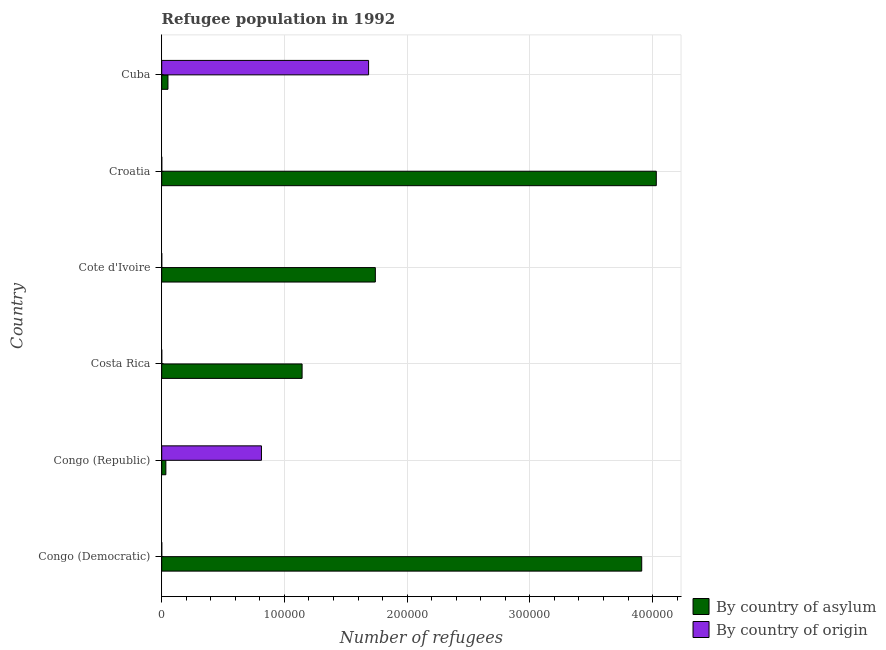How many different coloured bars are there?
Your answer should be compact. 2. How many groups of bars are there?
Provide a succinct answer. 6. Are the number of bars per tick equal to the number of legend labels?
Ensure brevity in your answer.  Yes. What is the label of the 1st group of bars from the top?
Your response must be concise. Cuba. What is the number of refugees by country of asylum in Croatia?
Provide a succinct answer. 4.03e+05. Across all countries, what is the maximum number of refugees by country of asylum?
Keep it short and to the point. 4.03e+05. Across all countries, what is the minimum number of refugees by country of origin?
Your answer should be compact. 2. In which country was the number of refugees by country of asylum maximum?
Your answer should be compact. Croatia. In which country was the number of refugees by country of asylum minimum?
Keep it short and to the point. Congo (Republic). What is the total number of refugees by country of asylum in the graph?
Make the answer very short. 1.09e+06. What is the difference between the number of refugees by country of origin in Congo (Republic) and that in Cuba?
Keep it short and to the point. -8.73e+04. What is the difference between the number of refugees by country of origin in Costa Rica and the number of refugees by country of asylum in Cote d'Ivoire?
Offer a very short reply. -1.74e+05. What is the average number of refugees by country of origin per country?
Provide a succinct answer. 4.16e+04. What is the difference between the number of refugees by country of origin and number of refugees by country of asylum in Congo (Republic)?
Offer a terse response. 7.79e+04. What is the ratio of the number of refugees by country of origin in Cote d'Ivoire to that in Cuba?
Your response must be concise. 0. Is the number of refugees by country of asylum in Congo (Democratic) less than that in Cote d'Ivoire?
Provide a short and direct response. No. Is the difference between the number of refugees by country of asylum in Costa Rica and Croatia greater than the difference between the number of refugees by country of origin in Costa Rica and Croatia?
Your answer should be compact. No. What is the difference between the highest and the second highest number of refugees by country of origin?
Provide a succinct answer. 8.73e+04. What is the difference between the highest and the lowest number of refugees by country of asylum?
Give a very brief answer. 4.00e+05. In how many countries, is the number of refugees by country of asylum greater than the average number of refugees by country of asylum taken over all countries?
Your answer should be very brief. 2. Is the sum of the number of refugees by country of asylum in Congo (Democratic) and Cuba greater than the maximum number of refugees by country of origin across all countries?
Your answer should be compact. Yes. What does the 2nd bar from the top in Congo (Democratic) represents?
Your answer should be very brief. By country of asylum. What does the 1st bar from the bottom in Cuba represents?
Give a very brief answer. By country of asylum. How many bars are there?
Keep it short and to the point. 12. Does the graph contain any zero values?
Ensure brevity in your answer.  No. Does the graph contain grids?
Give a very brief answer. Yes. Where does the legend appear in the graph?
Provide a short and direct response. Bottom right. How many legend labels are there?
Offer a terse response. 2. How are the legend labels stacked?
Your answer should be very brief. Vertical. What is the title of the graph?
Provide a succinct answer. Refugee population in 1992. Does "Non-residents" appear as one of the legend labels in the graph?
Your answer should be compact. No. What is the label or title of the X-axis?
Provide a succinct answer. Number of refugees. What is the label or title of the Y-axis?
Your response must be concise. Country. What is the Number of refugees in By country of asylum in Congo (Democratic)?
Your answer should be very brief. 3.91e+05. What is the Number of refugees of By country of origin in Congo (Democratic)?
Keep it short and to the point. 2. What is the Number of refugees in By country of asylum in Congo (Republic)?
Give a very brief answer. 3385. What is the Number of refugees in By country of origin in Congo (Republic)?
Provide a succinct answer. 8.13e+04. What is the Number of refugees of By country of asylum in Costa Rica?
Offer a terse response. 1.14e+05. What is the Number of refugees of By country of asylum in Cote d'Ivoire?
Make the answer very short. 1.74e+05. What is the Number of refugees in By country of asylum in Croatia?
Make the answer very short. 4.03e+05. What is the Number of refugees in By country of origin in Croatia?
Your response must be concise. 34. What is the Number of refugees in By country of asylum in Cuba?
Provide a short and direct response. 5092. What is the Number of refugees in By country of origin in Cuba?
Offer a very short reply. 1.69e+05. Across all countries, what is the maximum Number of refugees in By country of asylum?
Keep it short and to the point. 4.03e+05. Across all countries, what is the maximum Number of refugees in By country of origin?
Provide a short and direct response. 1.69e+05. Across all countries, what is the minimum Number of refugees of By country of asylum?
Ensure brevity in your answer.  3385. Across all countries, what is the minimum Number of refugees in By country of origin?
Provide a succinct answer. 2. What is the total Number of refugees in By country of asylum in the graph?
Your answer should be compact. 1.09e+06. What is the total Number of refugees of By country of origin in the graph?
Your response must be concise. 2.50e+05. What is the difference between the Number of refugees of By country of asylum in Congo (Democratic) and that in Congo (Republic)?
Your response must be concise. 3.88e+05. What is the difference between the Number of refugees of By country of origin in Congo (Democratic) and that in Congo (Republic)?
Provide a succinct answer. -8.13e+04. What is the difference between the Number of refugees of By country of asylum in Congo (Democratic) and that in Costa Rica?
Your answer should be compact. 2.77e+05. What is the difference between the Number of refugees in By country of origin in Congo (Democratic) and that in Costa Rica?
Provide a succinct answer. -5. What is the difference between the Number of refugees of By country of asylum in Congo (Democratic) and that in Cote d'Ivoire?
Give a very brief answer. 2.17e+05. What is the difference between the Number of refugees in By country of origin in Congo (Democratic) and that in Cote d'Ivoire?
Offer a very short reply. -3. What is the difference between the Number of refugees in By country of asylum in Congo (Democratic) and that in Croatia?
Ensure brevity in your answer.  -1.19e+04. What is the difference between the Number of refugees of By country of origin in Congo (Democratic) and that in Croatia?
Ensure brevity in your answer.  -32. What is the difference between the Number of refugees in By country of asylum in Congo (Democratic) and that in Cuba?
Your answer should be compact. 3.86e+05. What is the difference between the Number of refugees of By country of origin in Congo (Democratic) and that in Cuba?
Provide a succinct answer. -1.69e+05. What is the difference between the Number of refugees in By country of asylum in Congo (Republic) and that in Costa Rica?
Your answer should be compact. -1.11e+05. What is the difference between the Number of refugees in By country of origin in Congo (Republic) and that in Costa Rica?
Your response must be concise. 8.13e+04. What is the difference between the Number of refugees of By country of asylum in Congo (Republic) and that in Cote d'Ivoire?
Keep it short and to the point. -1.71e+05. What is the difference between the Number of refugees of By country of origin in Congo (Republic) and that in Cote d'Ivoire?
Your response must be concise. 8.13e+04. What is the difference between the Number of refugees in By country of asylum in Congo (Republic) and that in Croatia?
Ensure brevity in your answer.  -4.00e+05. What is the difference between the Number of refugees of By country of origin in Congo (Republic) and that in Croatia?
Your answer should be very brief. 8.12e+04. What is the difference between the Number of refugees of By country of asylum in Congo (Republic) and that in Cuba?
Give a very brief answer. -1707. What is the difference between the Number of refugees of By country of origin in Congo (Republic) and that in Cuba?
Ensure brevity in your answer.  -8.73e+04. What is the difference between the Number of refugees of By country of asylum in Costa Rica and that in Cote d'Ivoire?
Ensure brevity in your answer.  -5.97e+04. What is the difference between the Number of refugees in By country of origin in Costa Rica and that in Cote d'Ivoire?
Give a very brief answer. 2. What is the difference between the Number of refugees of By country of asylum in Costa Rica and that in Croatia?
Provide a short and direct response. -2.89e+05. What is the difference between the Number of refugees of By country of asylum in Costa Rica and that in Cuba?
Offer a terse response. 1.09e+05. What is the difference between the Number of refugees of By country of origin in Costa Rica and that in Cuba?
Give a very brief answer. -1.69e+05. What is the difference between the Number of refugees in By country of asylum in Cote d'Ivoire and that in Croatia?
Your answer should be very brief. -2.29e+05. What is the difference between the Number of refugees in By country of asylum in Cote d'Ivoire and that in Cuba?
Your answer should be very brief. 1.69e+05. What is the difference between the Number of refugees of By country of origin in Cote d'Ivoire and that in Cuba?
Ensure brevity in your answer.  -1.69e+05. What is the difference between the Number of refugees of By country of asylum in Croatia and that in Cuba?
Offer a terse response. 3.98e+05. What is the difference between the Number of refugees in By country of origin in Croatia and that in Cuba?
Make the answer very short. -1.69e+05. What is the difference between the Number of refugees of By country of asylum in Congo (Democratic) and the Number of refugees of By country of origin in Congo (Republic)?
Your answer should be very brief. 3.10e+05. What is the difference between the Number of refugees in By country of asylum in Congo (Democratic) and the Number of refugees in By country of origin in Costa Rica?
Your response must be concise. 3.91e+05. What is the difference between the Number of refugees in By country of asylum in Congo (Democratic) and the Number of refugees in By country of origin in Cote d'Ivoire?
Provide a succinct answer. 3.91e+05. What is the difference between the Number of refugees of By country of asylum in Congo (Democratic) and the Number of refugees of By country of origin in Croatia?
Give a very brief answer. 3.91e+05. What is the difference between the Number of refugees in By country of asylum in Congo (Democratic) and the Number of refugees in By country of origin in Cuba?
Offer a very short reply. 2.23e+05. What is the difference between the Number of refugees of By country of asylum in Congo (Republic) and the Number of refugees of By country of origin in Costa Rica?
Your answer should be compact. 3378. What is the difference between the Number of refugees of By country of asylum in Congo (Republic) and the Number of refugees of By country of origin in Cote d'Ivoire?
Your answer should be very brief. 3380. What is the difference between the Number of refugees in By country of asylum in Congo (Republic) and the Number of refugees in By country of origin in Croatia?
Your response must be concise. 3351. What is the difference between the Number of refugees in By country of asylum in Congo (Republic) and the Number of refugees in By country of origin in Cuba?
Offer a terse response. -1.65e+05. What is the difference between the Number of refugees in By country of asylum in Costa Rica and the Number of refugees in By country of origin in Cote d'Ivoire?
Your answer should be very brief. 1.14e+05. What is the difference between the Number of refugees in By country of asylum in Costa Rica and the Number of refugees in By country of origin in Croatia?
Offer a terse response. 1.14e+05. What is the difference between the Number of refugees in By country of asylum in Costa Rica and the Number of refugees in By country of origin in Cuba?
Your answer should be very brief. -5.42e+04. What is the difference between the Number of refugees in By country of asylum in Cote d'Ivoire and the Number of refugees in By country of origin in Croatia?
Ensure brevity in your answer.  1.74e+05. What is the difference between the Number of refugees in By country of asylum in Cote d'Ivoire and the Number of refugees in By country of origin in Cuba?
Offer a very short reply. 5505. What is the difference between the Number of refugees of By country of asylum in Croatia and the Number of refugees of By country of origin in Cuba?
Your answer should be compact. 2.34e+05. What is the average Number of refugees of By country of asylum per country?
Your answer should be very brief. 1.82e+05. What is the average Number of refugees in By country of origin per country?
Provide a succinct answer. 4.16e+04. What is the difference between the Number of refugees of By country of asylum and Number of refugees of By country of origin in Congo (Democratic)?
Keep it short and to the point. 3.91e+05. What is the difference between the Number of refugees in By country of asylum and Number of refugees in By country of origin in Congo (Republic)?
Offer a terse response. -7.79e+04. What is the difference between the Number of refugees of By country of asylum and Number of refugees of By country of origin in Costa Rica?
Your answer should be very brief. 1.14e+05. What is the difference between the Number of refugees in By country of asylum and Number of refugees in By country of origin in Cote d'Ivoire?
Provide a succinct answer. 1.74e+05. What is the difference between the Number of refugees in By country of asylum and Number of refugees in By country of origin in Croatia?
Ensure brevity in your answer.  4.03e+05. What is the difference between the Number of refugees of By country of asylum and Number of refugees of By country of origin in Cuba?
Give a very brief answer. -1.63e+05. What is the ratio of the Number of refugees of By country of asylum in Congo (Democratic) to that in Congo (Republic)?
Offer a very short reply. 115.55. What is the ratio of the Number of refugees in By country of origin in Congo (Democratic) to that in Congo (Republic)?
Offer a terse response. 0. What is the ratio of the Number of refugees of By country of asylum in Congo (Democratic) to that in Costa Rica?
Keep it short and to the point. 3.42. What is the ratio of the Number of refugees in By country of origin in Congo (Democratic) to that in Costa Rica?
Your response must be concise. 0.29. What is the ratio of the Number of refugees in By country of asylum in Congo (Democratic) to that in Cote d'Ivoire?
Ensure brevity in your answer.  2.25. What is the ratio of the Number of refugees of By country of origin in Congo (Democratic) to that in Cote d'Ivoire?
Keep it short and to the point. 0.4. What is the ratio of the Number of refugees of By country of asylum in Congo (Democratic) to that in Croatia?
Your response must be concise. 0.97. What is the ratio of the Number of refugees in By country of origin in Congo (Democratic) to that in Croatia?
Give a very brief answer. 0.06. What is the ratio of the Number of refugees in By country of asylum in Congo (Democratic) to that in Cuba?
Your answer should be very brief. 76.81. What is the ratio of the Number of refugees in By country of origin in Congo (Democratic) to that in Cuba?
Offer a very short reply. 0. What is the ratio of the Number of refugees in By country of asylum in Congo (Republic) to that in Costa Rica?
Provide a succinct answer. 0.03. What is the ratio of the Number of refugees in By country of origin in Congo (Republic) to that in Costa Rica?
Provide a short and direct response. 1.16e+04. What is the ratio of the Number of refugees in By country of asylum in Congo (Republic) to that in Cote d'Ivoire?
Ensure brevity in your answer.  0.02. What is the ratio of the Number of refugees of By country of origin in Congo (Republic) to that in Cote d'Ivoire?
Keep it short and to the point. 1.63e+04. What is the ratio of the Number of refugees in By country of asylum in Congo (Republic) to that in Croatia?
Offer a very short reply. 0.01. What is the ratio of the Number of refugees of By country of origin in Congo (Republic) to that in Croatia?
Your response must be concise. 2390.26. What is the ratio of the Number of refugees in By country of asylum in Congo (Republic) to that in Cuba?
Your answer should be compact. 0.66. What is the ratio of the Number of refugees in By country of origin in Congo (Republic) to that in Cuba?
Your answer should be very brief. 0.48. What is the ratio of the Number of refugees in By country of asylum in Costa Rica to that in Cote d'Ivoire?
Offer a very short reply. 0.66. What is the ratio of the Number of refugees in By country of origin in Costa Rica to that in Cote d'Ivoire?
Ensure brevity in your answer.  1.4. What is the ratio of the Number of refugees of By country of asylum in Costa Rica to that in Croatia?
Your response must be concise. 0.28. What is the ratio of the Number of refugees in By country of origin in Costa Rica to that in Croatia?
Make the answer very short. 0.21. What is the ratio of the Number of refugees in By country of asylum in Costa Rica to that in Cuba?
Provide a succinct answer. 22.46. What is the ratio of the Number of refugees of By country of origin in Costa Rica to that in Cuba?
Keep it short and to the point. 0. What is the ratio of the Number of refugees of By country of asylum in Cote d'Ivoire to that in Croatia?
Your answer should be compact. 0.43. What is the ratio of the Number of refugees of By country of origin in Cote d'Ivoire to that in Croatia?
Give a very brief answer. 0.15. What is the ratio of the Number of refugees in By country of asylum in Cote d'Ivoire to that in Cuba?
Ensure brevity in your answer.  34.19. What is the ratio of the Number of refugees in By country of origin in Cote d'Ivoire to that in Cuba?
Provide a succinct answer. 0. What is the ratio of the Number of refugees of By country of asylum in Croatia to that in Cuba?
Ensure brevity in your answer.  79.14. What is the ratio of the Number of refugees in By country of origin in Croatia to that in Cuba?
Offer a very short reply. 0. What is the difference between the highest and the second highest Number of refugees of By country of asylum?
Your answer should be compact. 1.19e+04. What is the difference between the highest and the second highest Number of refugees of By country of origin?
Your response must be concise. 8.73e+04. What is the difference between the highest and the lowest Number of refugees in By country of asylum?
Ensure brevity in your answer.  4.00e+05. What is the difference between the highest and the lowest Number of refugees of By country of origin?
Make the answer very short. 1.69e+05. 